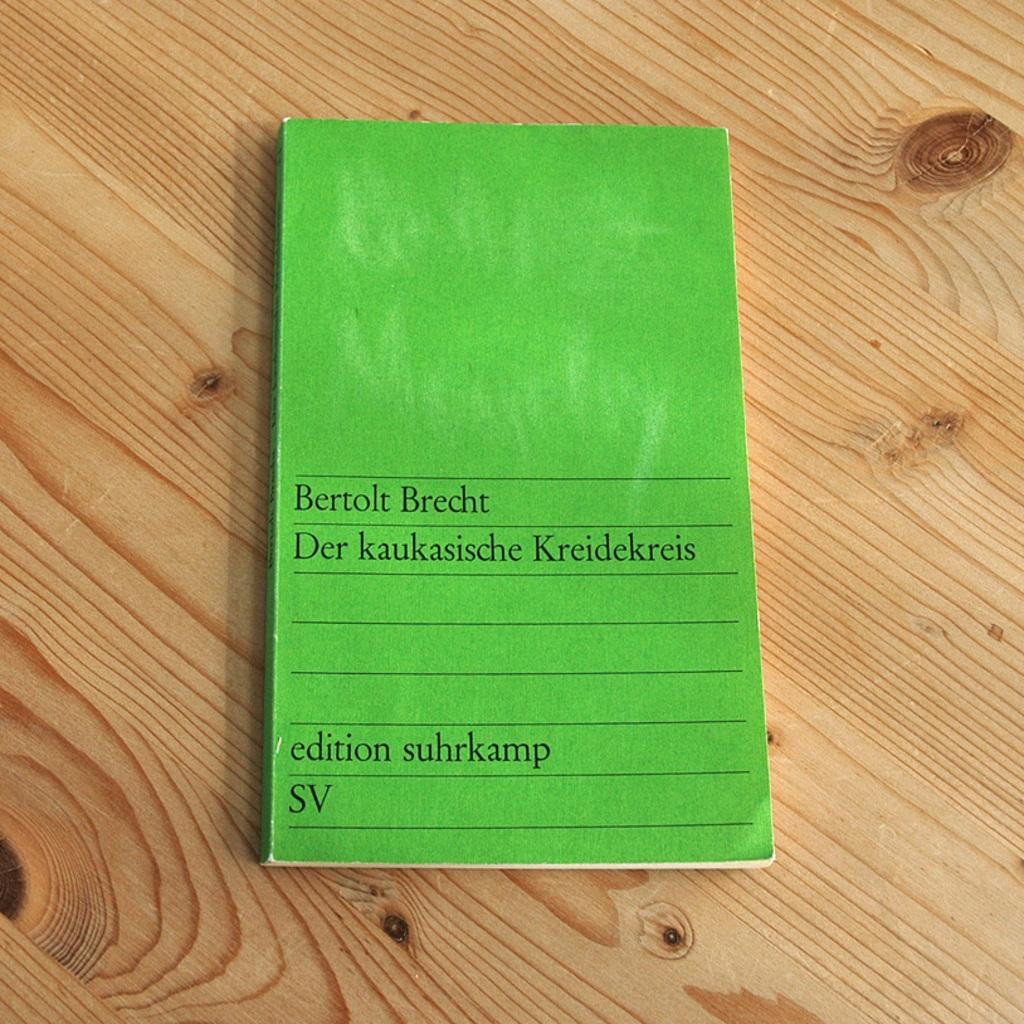<image>
Offer a succinct explanation of the picture presented. A bright green book written by Bertolt Brecht 